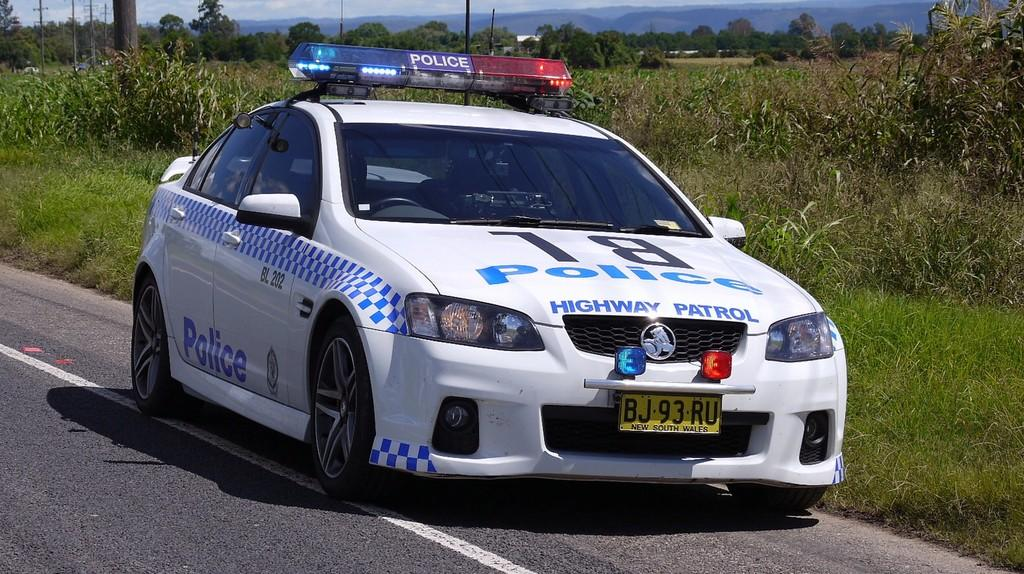What is the main subject in the center of the image? There is a car in the center of the image. What is located at the bottom of the image? There is a road at the bottom of the image. What type of vegetation can be seen in the image? Grass is present in the image. What can be seen in the background of the image? There are trees, poles, and mountains in the background of the image. What else is present in the background of the image? There are plants in the background of the image. What type of liquid can be seen flowing from the car in the image? There is no liquid flowing from the car in the image. 